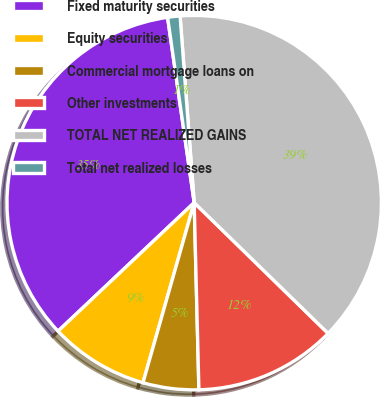Convert chart. <chart><loc_0><loc_0><loc_500><loc_500><pie_chart><fcel>Fixed maturity securities<fcel>Equity securities<fcel>Commercial mortgage loans on<fcel>Other investments<fcel>TOTAL NET REALIZED GAINS<fcel>Total net realized losses<nl><fcel>34.77%<fcel>8.55%<fcel>4.81%<fcel>12.29%<fcel>38.51%<fcel>1.07%<nl></chart> 